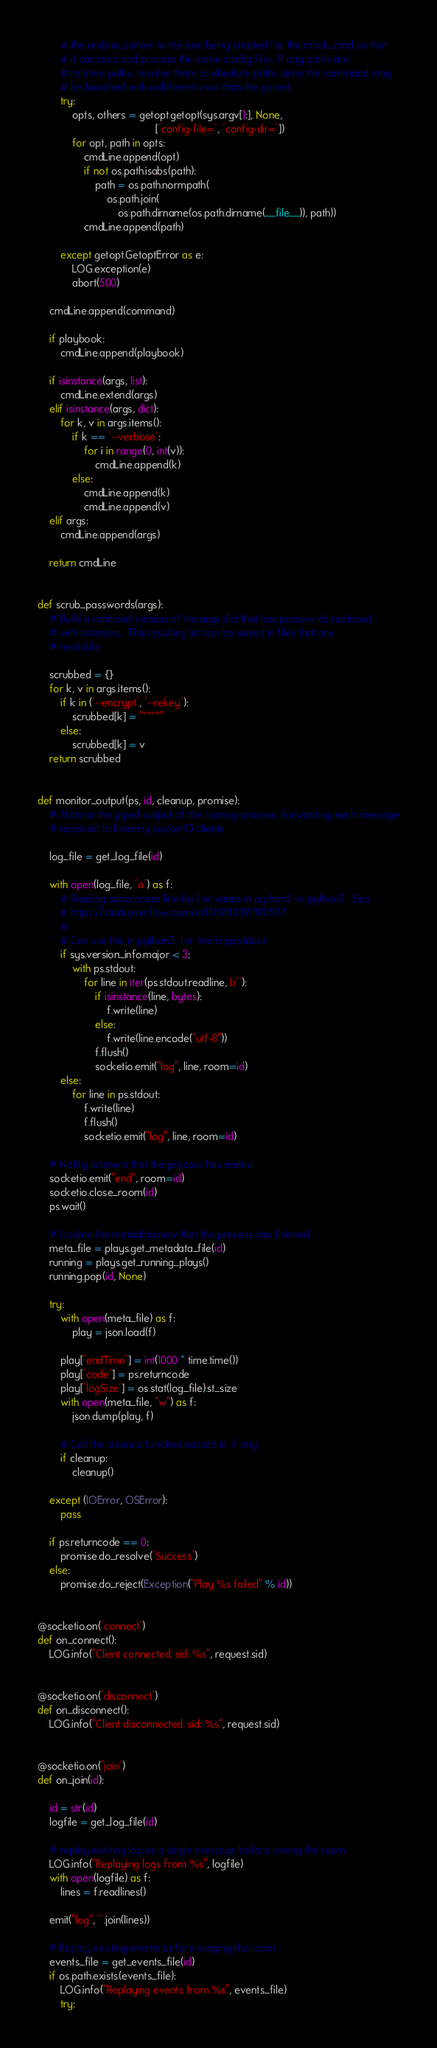<code> <loc_0><loc_0><loc_500><loc_500><_Python_>        # the ardana_server to the one being created for the mock_cmd so that
        # it can read and process the same config files. If any paths are
        # relative paths, resolve them to absolute paths since the command may
        # be launched with a different cwd than the parent.
        try:
            opts, others = getopt.getopt(sys.argv[1:], None,
                                         ['config-file=', 'config-dir='])
            for opt, path in opts:
                cmdLine.append(opt)
                if not os.path.isabs(path):
                    path = os.path.normpath(
                        os.path.join(
                            os.path.dirname(os.path.dirname(__file__)), path))
                cmdLine.append(path)

        except getopt.GetoptError as e:
            LOG.exception(e)
            abort(500)

    cmdLine.append(command)

    if playbook:
        cmdLine.append(playbook)

    if isinstance(args, list):
        cmdLine.extend(args)
    elif isinstance(args, dict):
        for k, v in args.items():
            if k == '--verbose':
                for i in range(0, int(v)):
                    cmdLine.append(k)
            else:
                cmdLine.append(k)
                cmdLine.append(v)
    elif args:
        cmdLine.append(args)

    return cmdLine


def scrub_passwords(args):
    # Build a sanitized version of the args dict that has passwords replaced
    # with asterisks.  This resulting list can be saved in files that are
    # readable

    scrubbed = {}
    for k, v in args.items():
        if k in ('--encrypt', '--rekey'):
            scrubbed[k] = "****"
        else:
            scrubbed[k] = v
    return scrubbed


def monitor_output(ps, id, cleanup, promise):
    # Monitor the piped output of the running process, forwarding each message
    # received to listening socketIO clients

    log_file = get_log_file(id)

    with open(log_file, 'a') as f:
        # Reading subprocess line by line varies in python2 vs python3.  See
        # https://stackoverflow.com/a/17698359/190597
        #
        # Can use this in python3: for line in ps.stdout:
        if sys.version_info.major < 3:
            with ps.stdout:
                for line in iter(ps.stdout.readline, b''):
                    if isinstance(line, bytes):
                        f.write(line)
                    else:
                        f.write(line.encode("utf-8"))
                    f.flush()
                    socketio.emit("log", line, room=id)
        else:
            for line in ps.stdout:
                f.write(line)
                f.flush()
                socketio.emit("log", line, room=id)

    # Notify listeners that the process has ended
    socketio.emit("end", room=id)
    socketio.close_room(id)
    ps.wait()

    # Update the metadata now that the process has finished.
    meta_file = plays.get_metadata_file(id)
    running = plays.get_running_plays()
    running.pop(id, None)

    try:
        with open(meta_file) as f:
            play = json.load(f)

        play['endTime'] = int(1000 * time.time())
        play['code'] = ps.returncode
        play['logSize'] = os.stat(log_file).st_size
        with open(meta_file, "w") as f:
            json.dump(play, f)

        # Call the cleanup function passed in, if any
        if cleanup:
            cleanup()

    except (IOError, OSError):
        pass

    if ps.returncode == 0:
        promise.do_resolve('Success')
    else:
        promise.do_reject(Exception("Play %s failed" % id))


@socketio.on('connect')
def on_connect():
    LOG.info("Client connected. sid: %s", request.sid)


@socketio.on('disconnect')
def on_disconnect():
    LOG.info("Client disconnected. sid: %s", request.sid)


@socketio.on('join')
def on_join(id):

    id = str(id)
    logfile = get_log_file(id)

    # replay existing log as a single message before joining the room
    LOG.info("Replaying logs from %s", logfile)
    with open(logfile) as f:
        lines = f.readlines()

    emit("log", ''.join(lines))

    # Replay existing events before joinging the room
    events_file = get_events_file(id)
    if os.path.exists(events_file):
        LOG.info("Replaying events from %s", events_file)
        try:</code> 